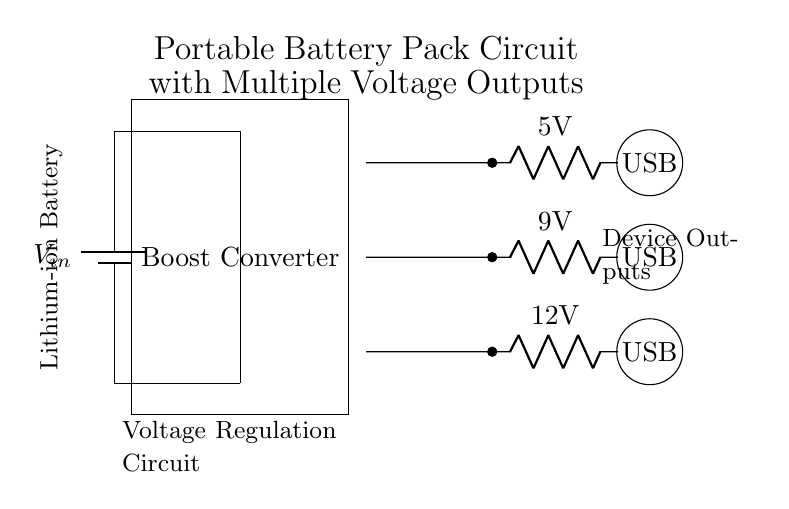What type of battery is used? The circuit indicates a Lithium-ion battery, which is labeled in the diagram.
Answer: Lithium-ion What is the maximum output voltage from the boost converter? The boost converter in the diagram provides three output voltages: 5V, 9V, and 12V, so the maximum is 12V.
Answer: 12V How many USB ports are included? There are three USB ports in the diagram, each positioned next to the outputs for different voltage levels.
Answer: Three What function does the boost converter serve? The boost converter steps up the voltage from the input source to the required output voltages for the devices, enabling multiple output options.
Answer: Voltage regulation Which component is responsible for increasing the voltage? The boost converter is specified in the diagram to perform the function of increasing or boosting the input voltage for outputs.
Answer: Boost converter What is the voltage of the output labeled with a '5V'? The output labeled 'R' signifies a resistance with a voltage of 5V connected to it, as indicated in the diagram.
Answer: 5V What is the role of the three resistance labels in the circuit? The resistances labeled 5V, 9V, and 12V represent different output voltage levels available from the boost converter for connecting various devices.
Answer: Output voltage levels 